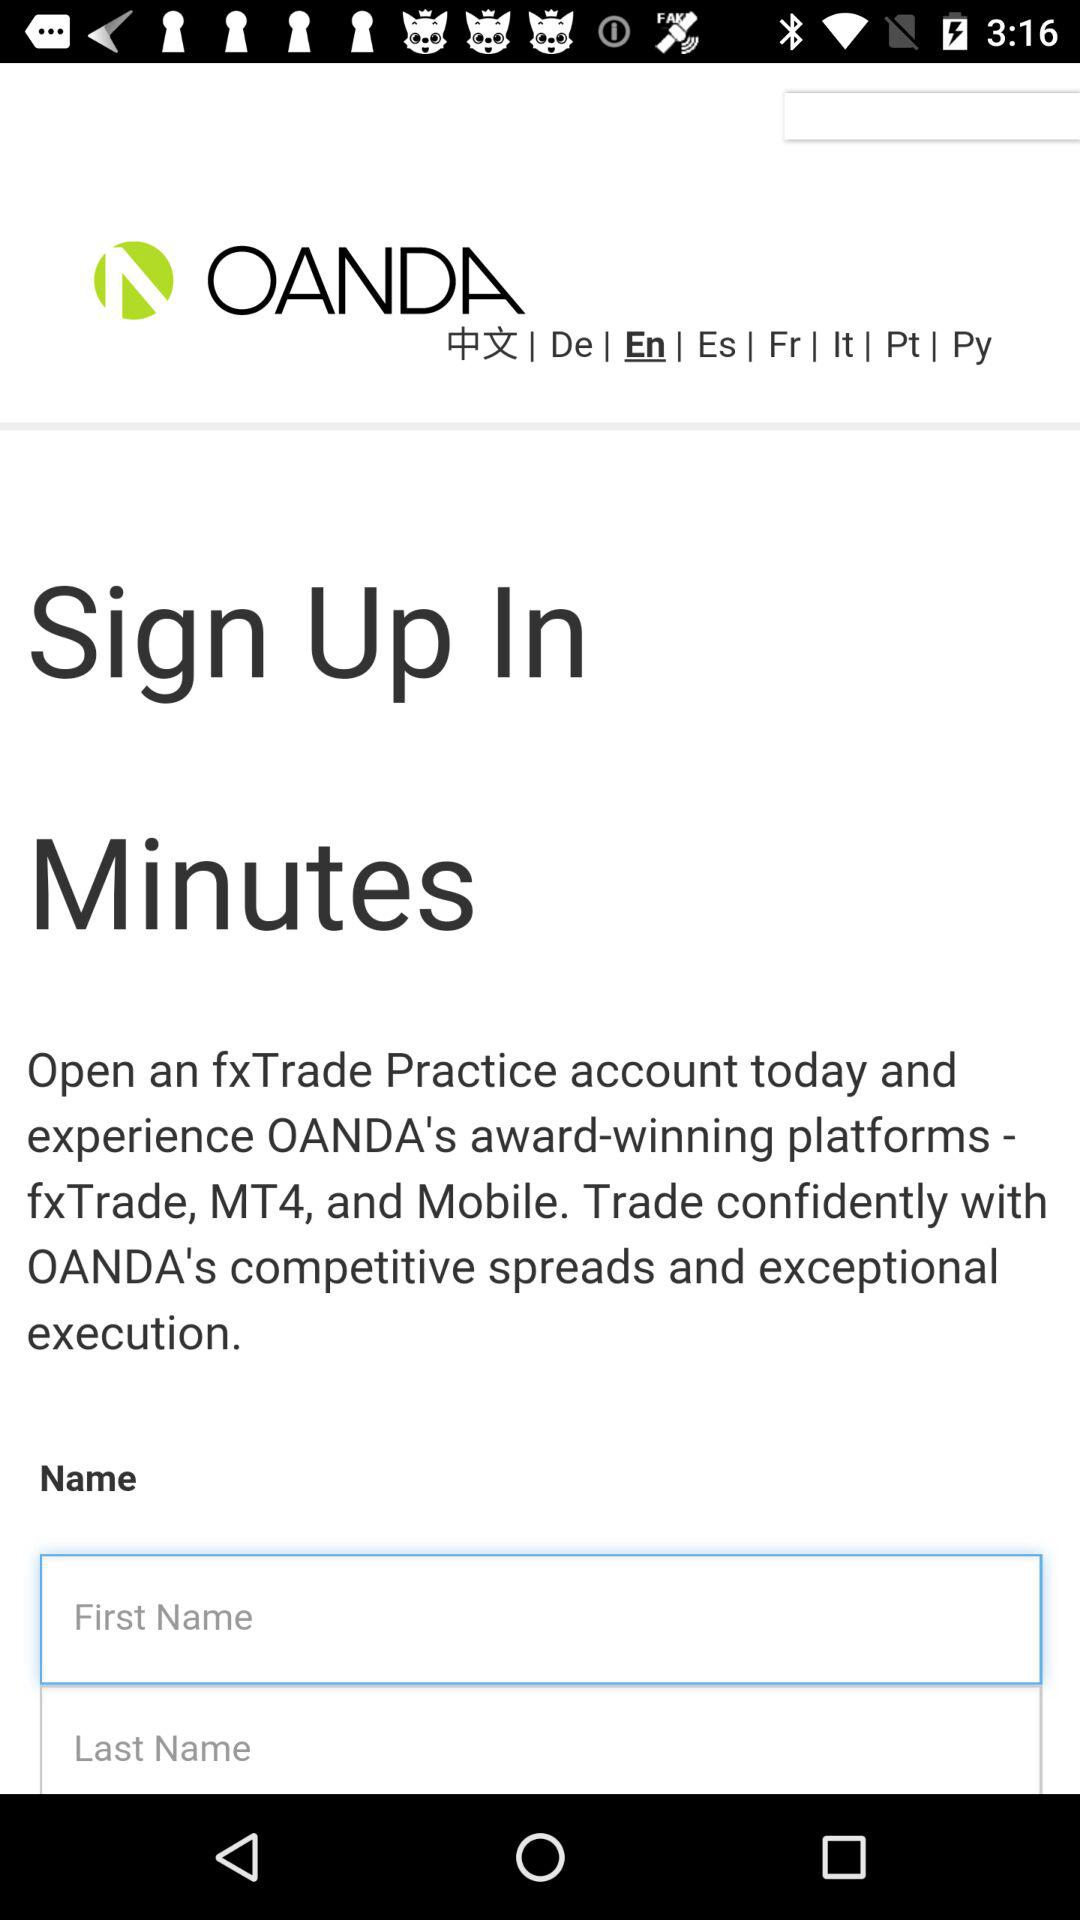How many text inputs are there for the user to enter their name? 2 